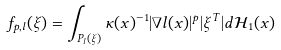Convert formula to latex. <formula><loc_0><loc_0><loc_500><loc_500>f _ { p , l } ( \xi ) = \int _ { P _ { l } ( \xi ) } \kappa ( x ) ^ { - 1 } | \nabla l ( x ) | ^ { p } | \xi ^ { T } | d \mathcal { H } _ { 1 } ( x )</formula> 